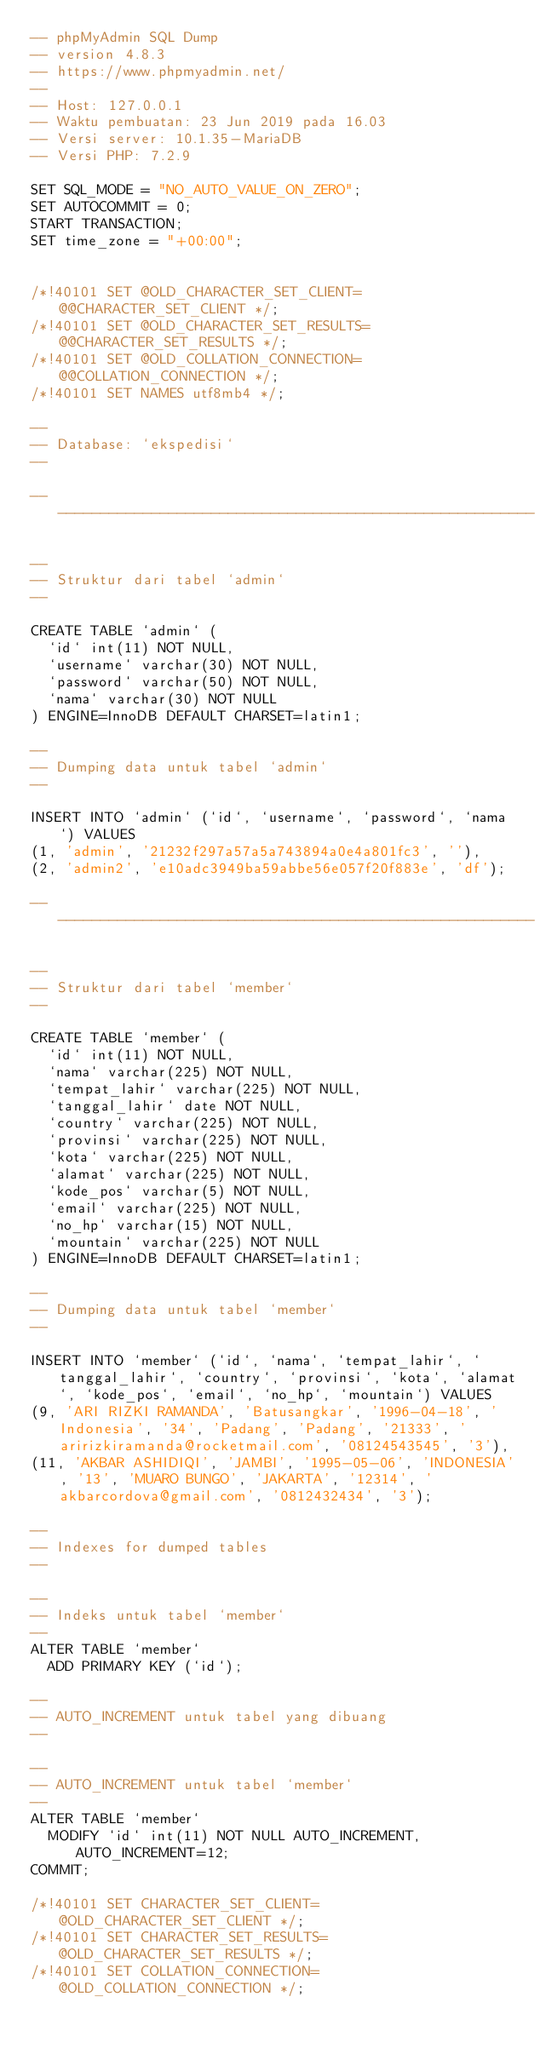<code> <loc_0><loc_0><loc_500><loc_500><_SQL_>-- phpMyAdmin SQL Dump
-- version 4.8.3
-- https://www.phpmyadmin.net/
--
-- Host: 127.0.0.1
-- Waktu pembuatan: 23 Jun 2019 pada 16.03
-- Versi server: 10.1.35-MariaDB
-- Versi PHP: 7.2.9

SET SQL_MODE = "NO_AUTO_VALUE_ON_ZERO";
SET AUTOCOMMIT = 0;
START TRANSACTION;
SET time_zone = "+00:00";


/*!40101 SET @OLD_CHARACTER_SET_CLIENT=@@CHARACTER_SET_CLIENT */;
/*!40101 SET @OLD_CHARACTER_SET_RESULTS=@@CHARACTER_SET_RESULTS */;
/*!40101 SET @OLD_COLLATION_CONNECTION=@@COLLATION_CONNECTION */;
/*!40101 SET NAMES utf8mb4 */;

--
-- Database: `ekspedisi`
--

-- --------------------------------------------------------

--
-- Struktur dari tabel `admin`
--

CREATE TABLE `admin` (
  `id` int(11) NOT NULL,
  `username` varchar(30) NOT NULL,
  `password` varchar(50) NOT NULL,
  `nama` varchar(30) NOT NULL
) ENGINE=InnoDB DEFAULT CHARSET=latin1;

--
-- Dumping data untuk tabel `admin`
--

INSERT INTO `admin` (`id`, `username`, `password`, `nama`) VALUES
(1, 'admin', '21232f297a57a5a743894a0e4a801fc3', ''),
(2, 'admin2', 'e10adc3949ba59abbe56e057f20f883e', 'df');

-- --------------------------------------------------------

--
-- Struktur dari tabel `member`
--

CREATE TABLE `member` (
  `id` int(11) NOT NULL,
  `nama` varchar(225) NOT NULL,
  `tempat_lahir` varchar(225) NOT NULL,
  `tanggal_lahir` date NOT NULL,
  `country` varchar(225) NOT NULL,
  `provinsi` varchar(225) NOT NULL,
  `kota` varchar(225) NOT NULL,
  `alamat` varchar(225) NOT NULL,
  `kode_pos` varchar(5) NOT NULL,
  `email` varchar(225) NOT NULL,
  `no_hp` varchar(15) NOT NULL,
  `mountain` varchar(225) NOT NULL
) ENGINE=InnoDB DEFAULT CHARSET=latin1;

--
-- Dumping data untuk tabel `member`
--

INSERT INTO `member` (`id`, `nama`, `tempat_lahir`, `tanggal_lahir`, `country`, `provinsi`, `kota`, `alamat`, `kode_pos`, `email`, `no_hp`, `mountain`) VALUES
(9, 'ARI RIZKI RAMANDA', 'Batusangkar', '1996-04-18', 'Indonesia', '34', 'Padang', 'Padang', '21333', 'aririzkiramanda@rocketmail.com', '08124543545', '3'),
(11, 'AKBAR ASHIDIQI', 'JAMBI', '1995-05-06', 'INDONESIA', '13', 'MUARO BUNGO', 'JAKARTA', '12314', 'akbarcordova@gmail.com', '0812432434', '3');

--
-- Indexes for dumped tables
--

--
-- Indeks untuk tabel `member`
--
ALTER TABLE `member`
  ADD PRIMARY KEY (`id`);

--
-- AUTO_INCREMENT untuk tabel yang dibuang
--

--
-- AUTO_INCREMENT untuk tabel `member`
--
ALTER TABLE `member`
  MODIFY `id` int(11) NOT NULL AUTO_INCREMENT, AUTO_INCREMENT=12;
COMMIT;

/*!40101 SET CHARACTER_SET_CLIENT=@OLD_CHARACTER_SET_CLIENT */;
/*!40101 SET CHARACTER_SET_RESULTS=@OLD_CHARACTER_SET_RESULTS */;
/*!40101 SET COLLATION_CONNECTION=@OLD_COLLATION_CONNECTION */;
</code> 